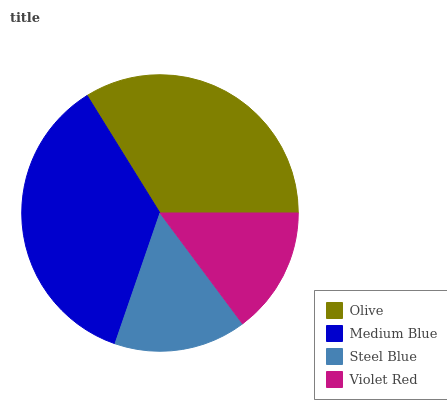Is Violet Red the minimum?
Answer yes or no. Yes. Is Medium Blue the maximum?
Answer yes or no. Yes. Is Steel Blue the minimum?
Answer yes or no. No. Is Steel Blue the maximum?
Answer yes or no. No. Is Medium Blue greater than Steel Blue?
Answer yes or no. Yes. Is Steel Blue less than Medium Blue?
Answer yes or no. Yes. Is Steel Blue greater than Medium Blue?
Answer yes or no. No. Is Medium Blue less than Steel Blue?
Answer yes or no. No. Is Olive the high median?
Answer yes or no. Yes. Is Steel Blue the low median?
Answer yes or no. Yes. Is Medium Blue the high median?
Answer yes or no. No. Is Olive the low median?
Answer yes or no. No. 